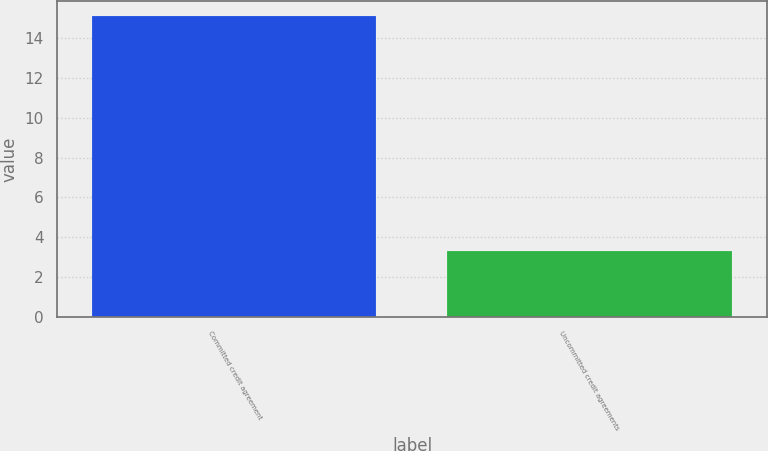Convert chart to OTSL. <chart><loc_0><loc_0><loc_500><loc_500><bar_chart><fcel>Committed credit agreement<fcel>Uncommitted credit agreements<nl><fcel>15.1<fcel>3.3<nl></chart> 